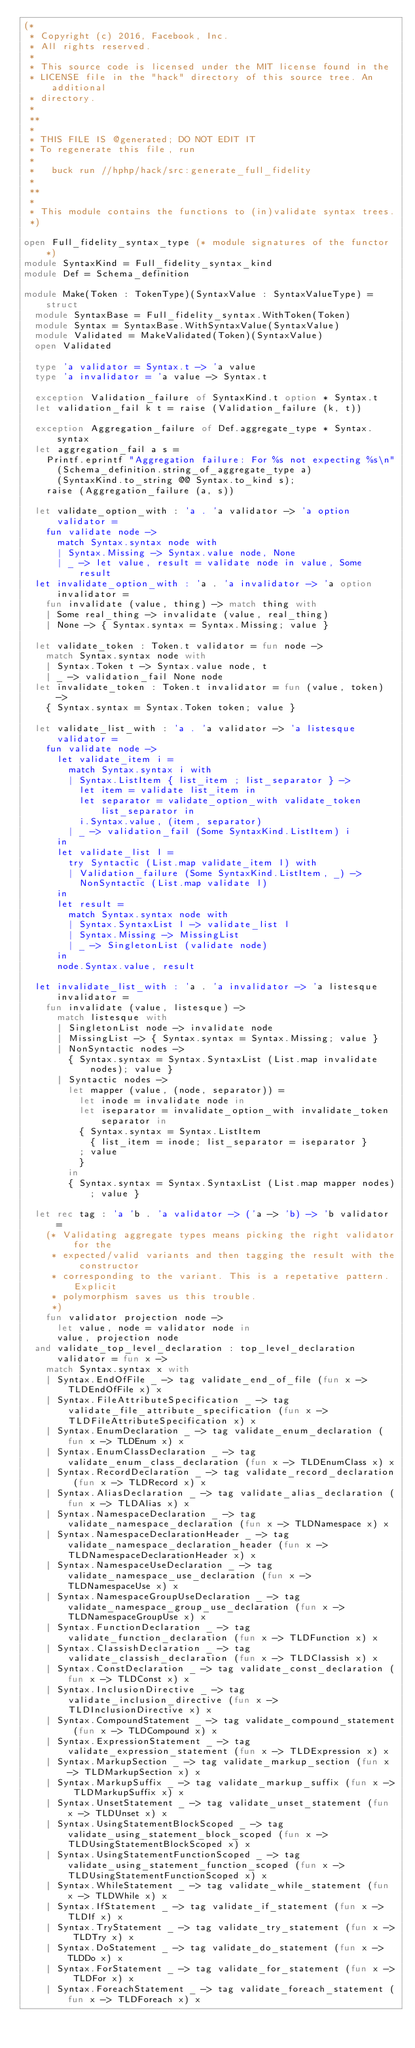Convert code to text. <code><loc_0><loc_0><loc_500><loc_500><_OCaml_>(*
 * Copyright (c) 2016, Facebook, Inc.
 * All rights reserved.
 *
 * This source code is licensed under the MIT license found in the
 * LICENSE file in the "hack" directory of this source tree. An additional
 * directory.
 *
 **
 *
 * THIS FILE IS @generated; DO NOT EDIT IT
 * To regenerate this file, run
 *
 *   buck run //hphp/hack/src:generate_full_fidelity
 *
 **
 *
 * This module contains the functions to (in)validate syntax trees.
 *)

open Full_fidelity_syntax_type (* module signatures of the functor *)
module SyntaxKind = Full_fidelity_syntax_kind
module Def = Schema_definition

module Make(Token : TokenType)(SyntaxValue : SyntaxValueType) = struct
  module SyntaxBase = Full_fidelity_syntax.WithToken(Token)
  module Syntax = SyntaxBase.WithSyntaxValue(SyntaxValue)
  module Validated = MakeValidated(Token)(SyntaxValue)
  open Validated

  type 'a validator = Syntax.t -> 'a value
  type 'a invalidator = 'a value -> Syntax.t

  exception Validation_failure of SyntaxKind.t option * Syntax.t
  let validation_fail k t = raise (Validation_failure (k, t))

  exception Aggregation_failure of Def.aggregate_type * Syntax.syntax
  let aggregation_fail a s =
    Printf.eprintf "Aggregation failure: For %s not expecting %s\n"
      (Schema_definition.string_of_aggregate_type a)
      (SyntaxKind.to_string @@ Syntax.to_kind s);
    raise (Aggregation_failure (a, s))

  let validate_option_with : 'a . 'a validator -> 'a option validator =
    fun validate node ->
      match Syntax.syntax node with
      | Syntax.Missing -> Syntax.value node, None
      | _ -> let value, result = validate node in value, Some result
  let invalidate_option_with : 'a . 'a invalidator -> 'a option invalidator =
    fun invalidate (value, thing) -> match thing with
    | Some real_thing -> invalidate (value, real_thing)
    | None -> { Syntax.syntax = Syntax.Missing; value }

  let validate_token : Token.t validator = fun node ->
    match Syntax.syntax node with
    | Syntax.Token t -> Syntax.value node, t
    | _ -> validation_fail None node
  let invalidate_token : Token.t invalidator = fun (value, token) ->
    { Syntax.syntax = Syntax.Token token; value }

  let validate_list_with : 'a . 'a validator -> 'a listesque validator =
    fun validate node ->
      let validate_item i =
        match Syntax.syntax i with
        | Syntax.ListItem { list_item ; list_separator } ->
          let item = validate list_item in
          let separator = validate_option_with validate_token list_separator in
          i.Syntax.value, (item, separator)
        | _ -> validation_fail (Some SyntaxKind.ListItem) i
      in
      let validate_list l =
        try Syntactic (List.map validate_item l) with
        | Validation_failure (Some SyntaxKind.ListItem, _) ->
          NonSyntactic (List.map validate l)
      in
      let result =
        match Syntax.syntax node with
        | Syntax.SyntaxList l -> validate_list l
        | Syntax.Missing -> MissingList
        | _ -> SingletonList (validate node)
      in
      node.Syntax.value, result

  let invalidate_list_with : 'a . 'a invalidator -> 'a listesque invalidator =
    fun invalidate (value, listesque) ->
      match listesque with
      | SingletonList node -> invalidate node
      | MissingList -> { Syntax.syntax = Syntax.Missing; value }
      | NonSyntactic nodes ->
        { Syntax.syntax = Syntax.SyntaxList (List.map invalidate nodes); value }
      | Syntactic nodes ->
        let mapper (value, (node, separator)) =
          let inode = invalidate node in
          let iseparator = invalidate_option_with invalidate_token separator in
          { Syntax.syntax = Syntax.ListItem
            { list_item = inode; list_separator = iseparator }
          ; value
          }
        in
        { Syntax.syntax = Syntax.SyntaxList (List.map mapper nodes); value }

  let rec tag : 'a 'b . 'a validator -> ('a -> 'b) -> 'b validator =
    (* Validating aggregate types means picking the right validator for the
     * expected/valid variants and then tagging the result with the constructor
     * corresponding to the variant. This is a repetative pattern. Explicit
     * polymorphism saves us this trouble.
     *)
    fun validator projection node ->
      let value, node = validator node in
      value, projection node
  and validate_top_level_declaration : top_level_declaration validator = fun x ->
    match Syntax.syntax x with
    | Syntax.EndOfFile _ -> tag validate_end_of_file (fun x -> TLDEndOfFile x) x
    | Syntax.FileAttributeSpecification _ -> tag validate_file_attribute_specification (fun x -> TLDFileAttributeSpecification x) x
    | Syntax.EnumDeclaration _ -> tag validate_enum_declaration (fun x -> TLDEnum x) x
    | Syntax.EnumClassDeclaration _ -> tag validate_enum_class_declaration (fun x -> TLDEnumClass x) x
    | Syntax.RecordDeclaration _ -> tag validate_record_declaration (fun x -> TLDRecord x) x
    | Syntax.AliasDeclaration _ -> tag validate_alias_declaration (fun x -> TLDAlias x) x
    | Syntax.NamespaceDeclaration _ -> tag validate_namespace_declaration (fun x -> TLDNamespace x) x
    | Syntax.NamespaceDeclarationHeader _ -> tag validate_namespace_declaration_header (fun x -> TLDNamespaceDeclarationHeader x) x
    | Syntax.NamespaceUseDeclaration _ -> tag validate_namespace_use_declaration (fun x -> TLDNamespaceUse x) x
    | Syntax.NamespaceGroupUseDeclaration _ -> tag validate_namespace_group_use_declaration (fun x -> TLDNamespaceGroupUse x) x
    | Syntax.FunctionDeclaration _ -> tag validate_function_declaration (fun x -> TLDFunction x) x
    | Syntax.ClassishDeclaration _ -> tag validate_classish_declaration (fun x -> TLDClassish x) x
    | Syntax.ConstDeclaration _ -> tag validate_const_declaration (fun x -> TLDConst x) x
    | Syntax.InclusionDirective _ -> tag validate_inclusion_directive (fun x -> TLDInclusionDirective x) x
    | Syntax.CompoundStatement _ -> tag validate_compound_statement (fun x -> TLDCompound x) x
    | Syntax.ExpressionStatement _ -> tag validate_expression_statement (fun x -> TLDExpression x) x
    | Syntax.MarkupSection _ -> tag validate_markup_section (fun x -> TLDMarkupSection x) x
    | Syntax.MarkupSuffix _ -> tag validate_markup_suffix (fun x -> TLDMarkupSuffix x) x
    | Syntax.UnsetStatement _ -> tag validate_unset_statement (fun x -> TLDUnset x) x
    | Syntax.UsingStatementBlockScoped _ -> tag validate_using_statement_block_scoped (fun x -> TLDUsingStatementBlockScoped x) x
    | Syntax.UsingStatementFunctionScoped _ -> tag validate_using_statement_function_scoped (fun x -> TLDUsingStatementFunctionScoped x) x
    | Syntax.WhileStatement _ -> tag validate_while_statement (fun x -> TLDWhile x) x
    | Syntax.IfStatement _ -> tag validate_if_statement (fun x -> TLDIf x) x
    | Syntax.TryStatement _ -> tag validate_try_statement (fun x -> TLDTry x) x
    | Syntax.DoStatement _ -> tag validate_do_statement (fun x -> TLDDo x) x
    | Syntax.ForStatement _ -> tag validate_for_statement (fun x -> TLDFor x) x
    | Syntax.ForeachStatement _ -> tag validate_foreach_statement (fun x -> TLDForeach x) x</code> 